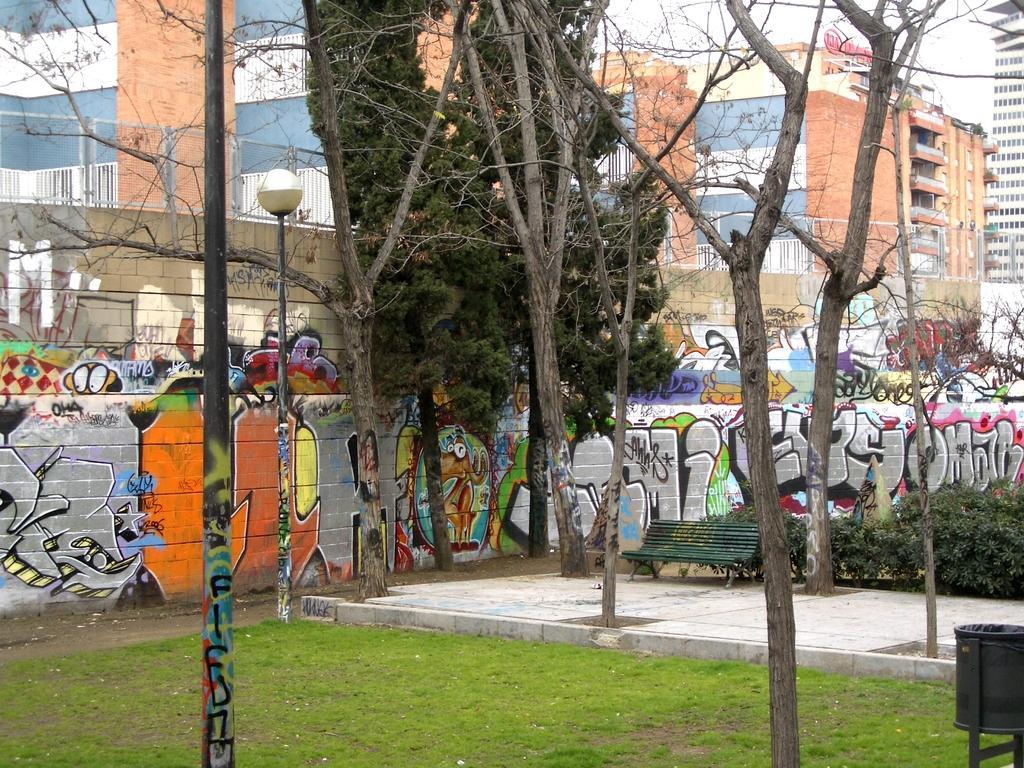Can you describe this image briefly? In this picture I can see the grass, path, few plants, a bench, a bin and the wall in front and I can see the art on the wall. I can also see few trees and a light pole. In the background I can see the buildings. 